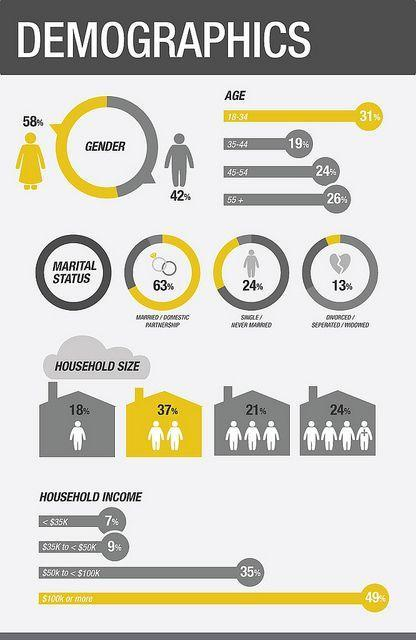What percentage with a household size as 1?
Answer the question with a short phrase. 18% What percentage with marital status "Single"? 24% What percentage with a household size as 3? 21% What percentage with marital status "Married"? 63% What percentage with a household size as 2? 37% 